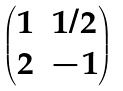<formula> <loc_0><loc_0><loc_500><loc_500>\begin{pmatrix} 1 & 1 / 2 \\ 2 & - 1 \end{pmatrix}</formula> 